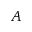<formula> <loc_0><loc_0><loc_500><loc_500>A</formula> 